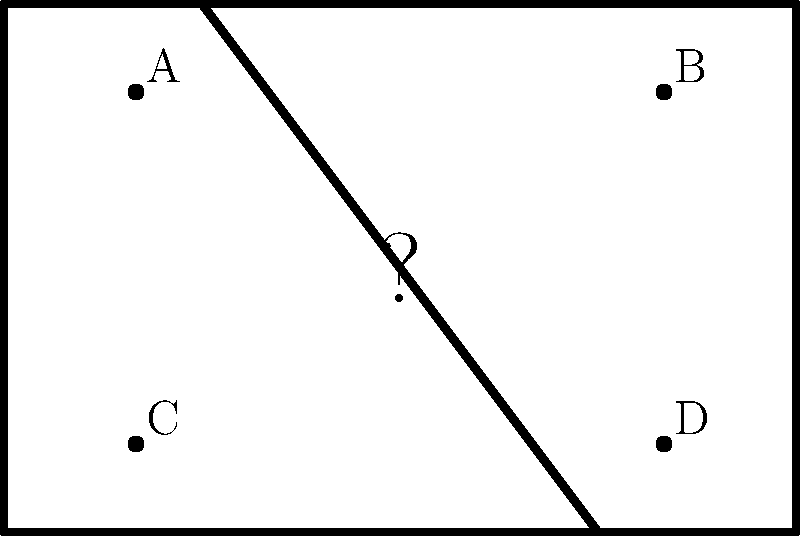Match the classic sitcom catchphrase "How you doin'?" to its corresponding visual scene represented by one of the points A, B, C, or D in the TV frame above. This iconic phrase was delivered with a charming smirk and a hint of flirtation. To answer this question, let's consider the following steps:

1. Recall that "How you doin'?" is a catchphrase from the popular sitcom "Friends" (1994-2004).

2. This phrase was famously associated with the character Joey Tribbiani, played by Matt LeBlanc.

3. Joey would typically use this phrase when flirting with women, often accompanied by a confident smile and a slight tilt of his head.

4. Given the description "delivered with a charming smirk and a hint of flirtation," we can imagine Joey's face positioned in the center of the TV screen, looking directly at the viewer.

5. Among the given options (A, B, C, D), the point that best represents this central, face-forward position would be closest to the center of the TV frame.

6. Examining the diagram, we can see that point C is located in the lower-left quadrant, which doesn't align with a centered face shot.

7. Point A is in the upper-left quadrant, which is also not ideal for a centered face shot.

8. Point D is in the lower-right quadrant, again not suitable for a centered face position.

9. Point B, located in the upper-right quadrant, is the closest to the center of the TV frame among the given options.

Therefore, point B would be the most appropriate choice to represent the visual scene corresponding to Joey's "How you doin'?" catchphrase.
Answer: B 